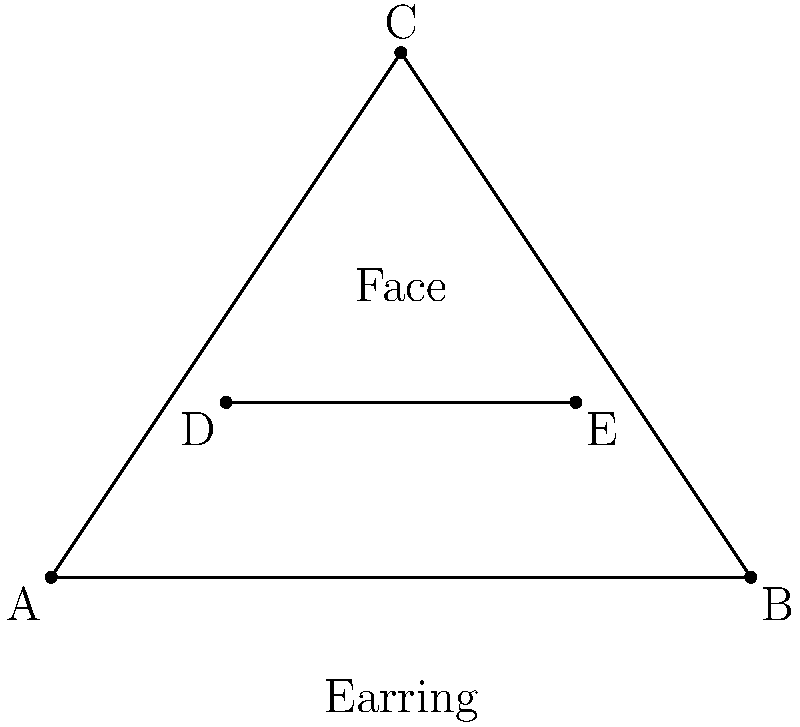When photographing a fashion blogger wearing triangular earrings, you notice that the earrings form an isosceles triangle ABC with base AB. Point D is located on AC and point E is on BC, such that DE is parallel to AB. If AD:DC = 1:2 and BE:EC = 1:2, what is the ratio of the length of DE to the length of AB? Let's approach this step-by-step:

1) Since ABC is an isosceles triangle with base AB, we know that AC = BC.

2) DE is parallel to AB, so triangle ABC is similar to triangle DEC.

3) We're given that AD:DC = 1:2 and BE:EC = 1:2. This means that D and E divide their respective sides in the same ratio.

4) In similar triangles, the ratio of corresponding sides is constant. Let's call this ratio $r$. Then:

   $r = \frac{DE}{AB} = \frac{DC}{AC} = \frac{EC}{BC}$

5) We know that $DC = \frac{2}{3}AC$ (because AD:DC = 1:2, so DC is 2/3 of AC).

6) Therefore, $r = \frac{DC}{AC} = \frac{2}{3}$

7) This means that $DE = \frac{2}{3}AB$

Therefore, the ratio of DE to AB is 2:3.
Answer: 2:3 